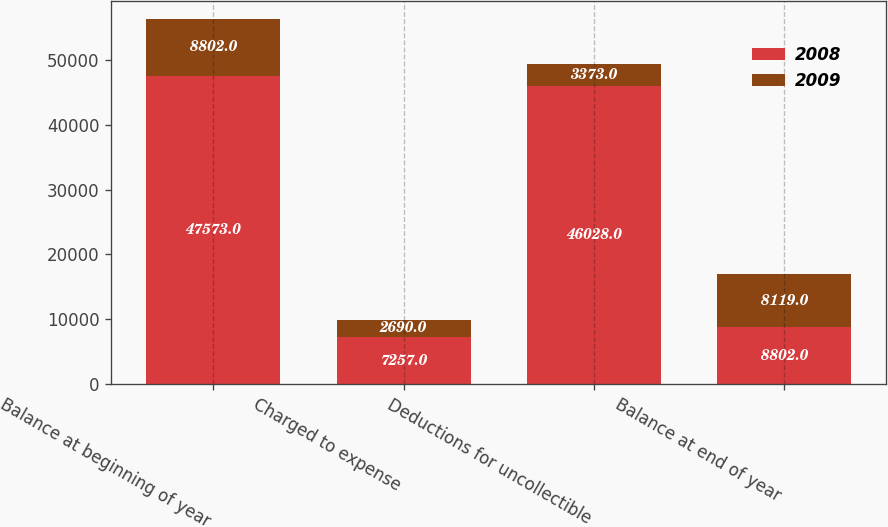<chart> <loc_0><loc_0><loc_500><loc_500><stacked_bar_chart><ecel><fcel>Balance at beginning of year<fcel>Charged to expense<fcel>Deductions for uncollectible<fcel>Balance at end of year<nl><fcel>2008<fcel>47573<fcel>7257<fcel>46028<fcel>8802<nl><fcel>2009<fcel>8802<fcel>2690<fcel>3373<fcel>8119<nl></chart> 